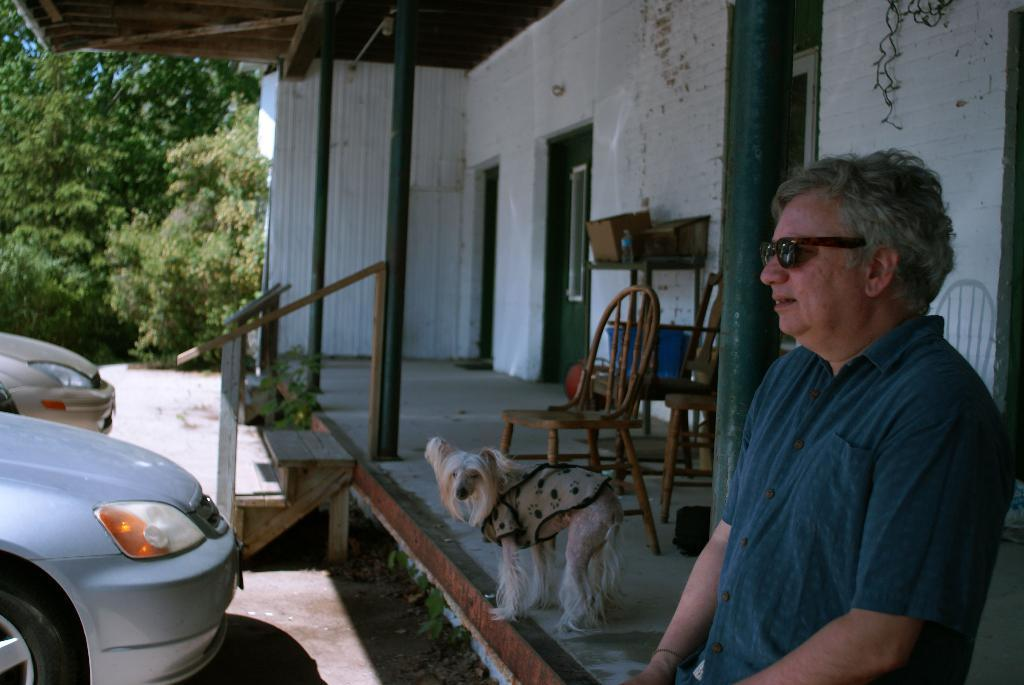What is located on the right side of the image? There is a man standing on the right side of the image. What is on the left side of the image? There is a car on the left side of the image. What is in the center of the image? There is a dog and a table in the center of the image. Are there any chairs in the image? Yes, there are chairs in the center of the image. What can be seen in the background of the image? There is a wall, a roof, and trees in the background of the image. What type of yarn is the dog holding in the image? There is no yarn present in the image; the dog is not holding anything. How does the growth of the car compare to the growth of the man? There is no comparison to be made, as the facts provided do not include any information about the growth of the car or the man. 